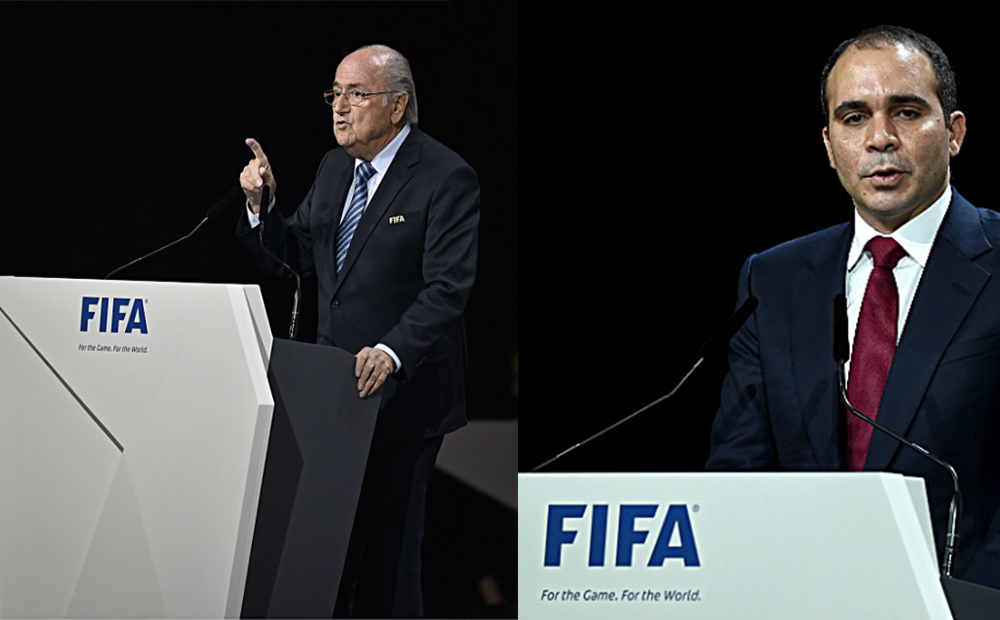How does the design of the lecterns and the overall stage setup contribute to the image's portrayal of these individuals? The sleek design of the lecterns, bearing the prominent FIFA branding, reflects a modern and professional image, instrumental in imparting a sense of power and sophistication. The stage setup, with its clean lines and focused lighting, draws the audience's attention to the speakers, reinforcing their importance. The visual impact of such a setting is to elevate the stature of the speakers, subconsciously communicating that their messages carry weight and significance. 